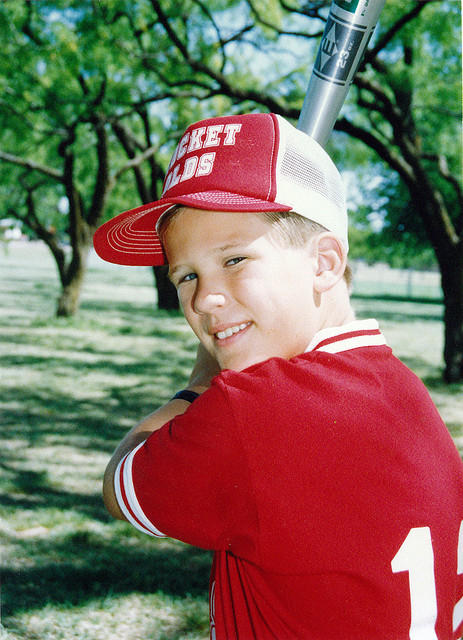<image>What kind of trees are in the background? I don't know what kind of trees are in the background. They could be oak, willow, or maple, among others. What kind of trees are in the background? It is unknown what kind of trees are in the background. There are different possibilities, such as fern, oak, willow, apple trees, or maple. 